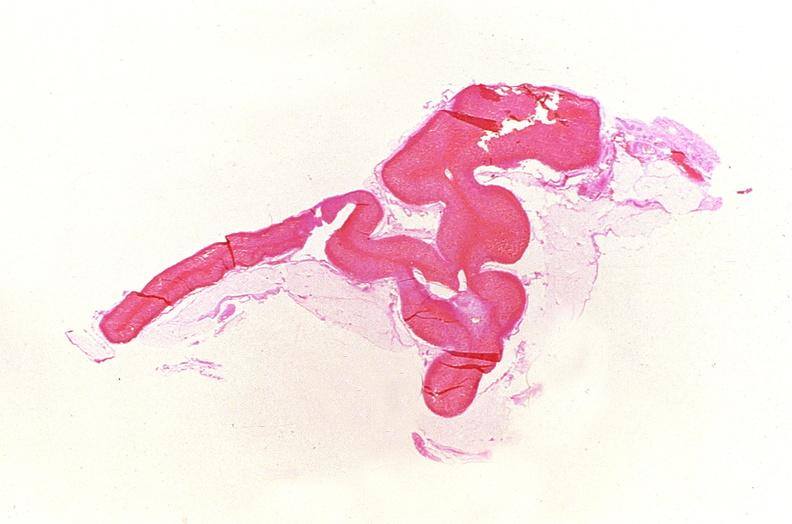s endocrine present?
Answer the question using a single word or phrase. Yes 